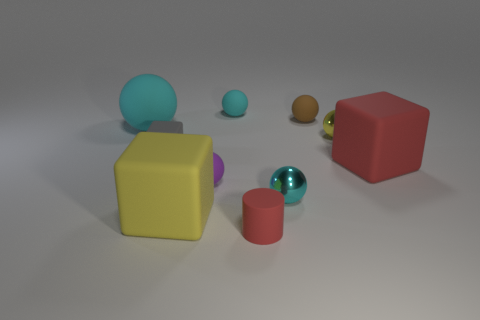Subtract all big rubber blocks. How many blocks are left? 1 Subtract all yellow cubes. How many cubes are left? 2 Subtract all gray cylinders. How many cyan balls are left? 3 Subtract all cylinders. How many objects are left? 9 Add 8 large rubber blocks. How many large rubber blocks are left? 10 Add 1 small purple rubber things. How many small purple rubber things exist? 2 Subtract 1 yellow blocks. How many objects are left? 9 Subtract all green cubes. Subtract all red cylinders. How many cubes are left? 3 Subtract all small yellow metal balls. Subtract all green metal spheres. How many objects are left? 9 